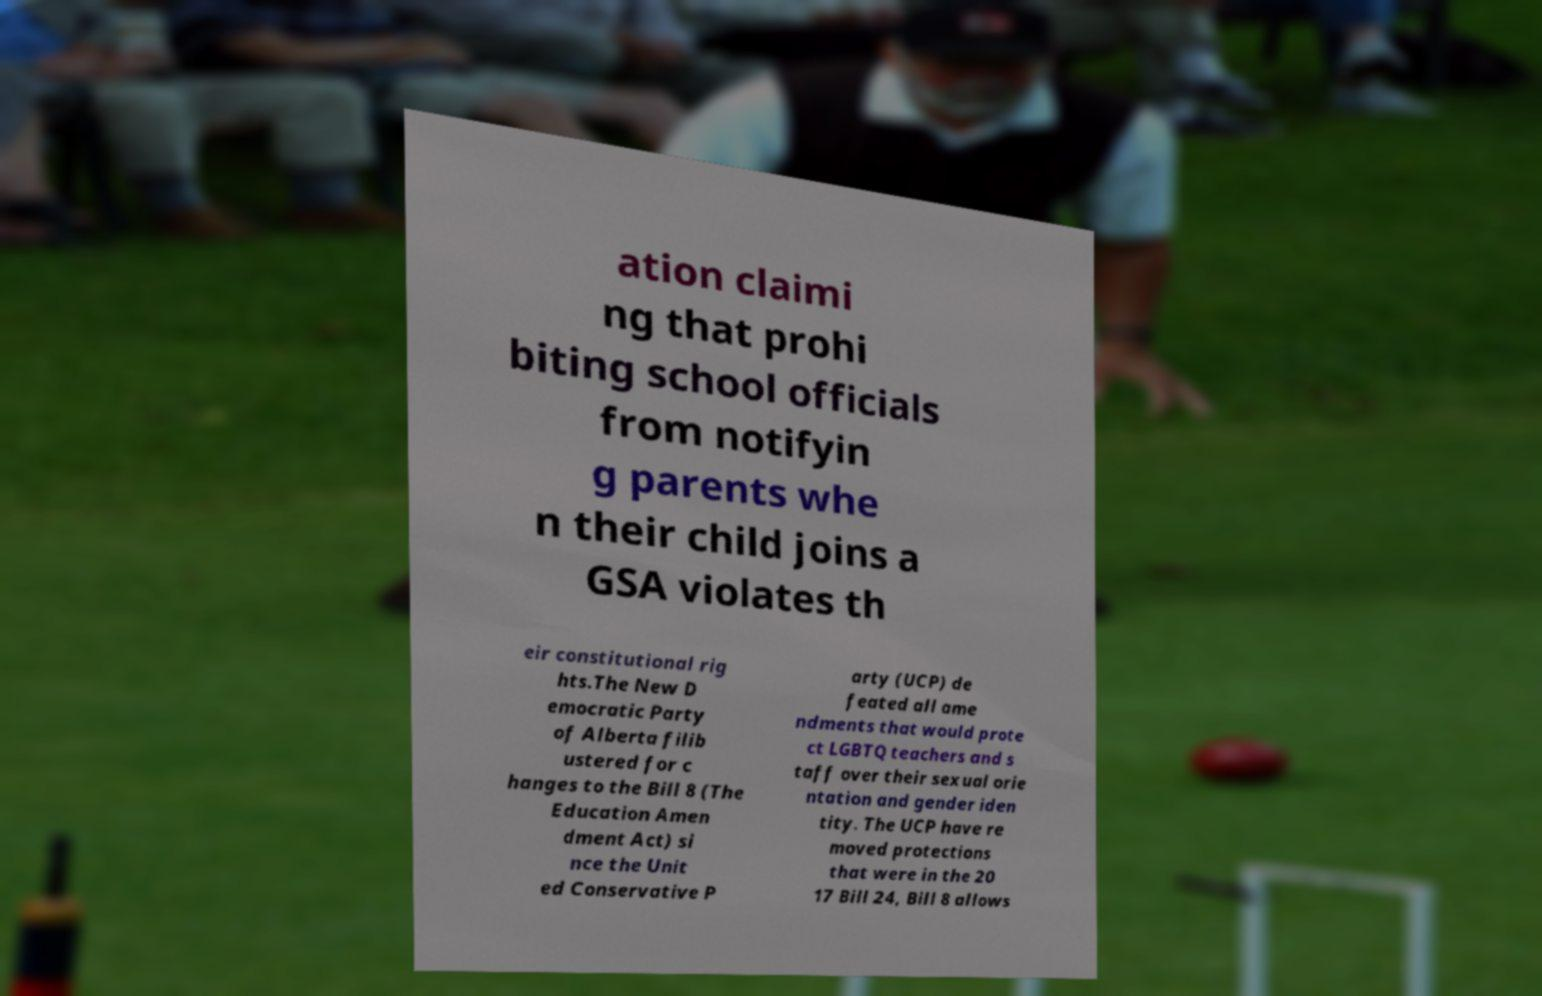Could you extract and type out the text from this image? ation claimi ng that prohi biting school officials from notifyin g parents whe n their child joins a GSA violates th eir constitutional rig hts.The New D emocratic Party of Alberta filib ustered for c hanges to the Bill 8 (The Education Amen dment Act) si nce the Unit ed Conservative P arty (UCP) de feated all ame ndments that would prote ct LGBTQ teachers and s taff over their sexual orie ntation and gender iden tity. The UCP have re moved protections that were in the 20 17 Bill 24, Bill 8 allows 